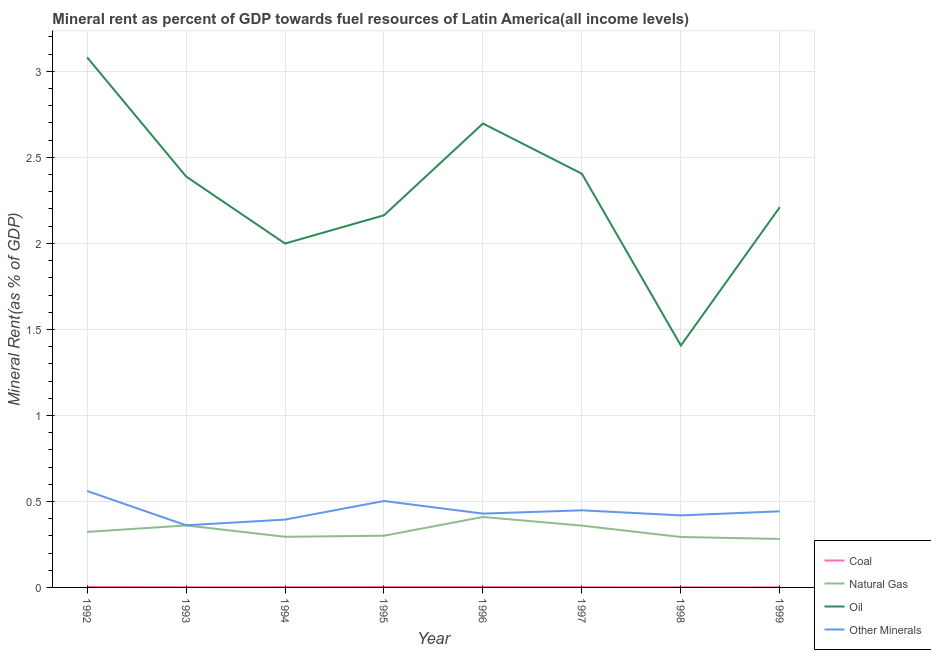Does the line corresponding to natural gas rent intersect with the line corresponding to oil rent?
Make the answer very short. No. What is the  rent of other minerals in 1995?
Ensure brevity in your answer.  0.5. Across all years, what is the maximum  rent of other minerals?
Provide a succinct answer. 0.56. Across all years, what is the minimum coal rent?
Offer a very short reply. 0. In which year was the  rent of other minerals maximum?
Make the answer very short. 1992. In which year was the  rent of other minerals minimum?
Offer a very short reply. 1993. What is the total  rent of other minerals in the graph?
Make the answer very short. 3.56. What is the difference between the natural gas rent in 1993 and that in 1994?
Make the answer very short. 0.07. What is the difference between the oil rent in 1997 and the coal rent in 1994?
Ensure brevity in your answer.  2.4. What is the average coal rent per year?
Your answer should be very brief. 0. In the year 1998, what is the difference between the  rent of other minerals and natural gas rent?
Ensure brevity in your answer.  0.13. What is the ratio of the oil rent in 1994 to that in 1997?
Provide a short and direct response. 0.83. What is the difference between the highest and the second highest  rent of other minerals?
Provide a succinct answer. 0.06. What is the difference between the highest and the lowest  rent of other minerals?
Offer a very short reply. 0.2. In how many years, is the  rent of other minerals greater than the average  rent of other minerals taken over all years?
Your answer should be very brief. 3. Does the natural gas rent monotonically increase over the years?
Offer a very short reply. No. Is the coal rent strictly less than the natural gas rent over the years?
Offer a terse response. Yes. What is the difference between two consecutive major ticks on the Y-axis?
Keep it short and to the point. 0.5. Are the values on the major ticks of Y-axis written in scientific E-notation?
Make the answer very short. No. Where does the legend appear in the graph?
Ensure brevity in your answer.  Bottom right. What is the title of the graph?
Your answer should be compact. Mineral rent as percent of GDP towards fuel resources of Latin America(all income levels). What is the label or title of the X-axis?
Your answer should be compact. Year. What is the label or title of the Y-axis?
Give a very brief answer. Mineral Rent(as % of GDP). What is the Mineral Rent(as % of GDP) of Coal in 1992?
Offer a very short reply. 0. What is the Mineral Rent(as % of GDP) in Natural Gas in 1992?
Your response must be concise. 0.32. What is the Mineral Rent(as % of GDP) of Oil in 1992?
Make the answer very short. 3.08. What is the Mineral Rent(as % of GDP) of Other Minerals in 1992?
Offer a terse response. 0.56. What is the Mineral Rent(as % of GDP) of Coal in 1993?
Your response must be concise. 0. What is the Mineral Rent(as % of GDP) in Natural Gas in 1993?
Keep it short and to the point. 0.36. What is the Mineral Rent(as % of GDP) of Oil in 1993?
Offer a terse response. 2.39. What is the Mineral Rent(as % of GDP) in Other Minerals in 1993?
Keep it short and to the point. 0.36. What is the Mineral Rent(as % of GDP) in Coal in 1994?
Offer a very short reply. 0. What is the Mineral Rent(as % of GDP) of Natural Gas in 1994?
Offer a terse response. 0.29. What is the Mineral Rent(as % of GDP) of Oil in 1994?
Provide a succinct answer. 2. What is the Mineral Rent(as % of GDP) in Other Minerals in 1994?
Make the answer very short. 0.39. What is the Mineral Rent(as % of GDP) in Coal in 1995?
Your answer should be compact. 0. What is the Mineral Rent(as % of GDP) of Natural Gas in 1995?
Provide a short and direct response. 0.3. What is the Mineral Rent(as % of GDP) in Oil in 1995?
Keep it short and to the point. 2.16. What is the Mineral Rent(as % of GDP) in Other Minerals in 1995?
Your response must be concise. 0.5. What is the Mineral Rent(as % of GDP) of Coal in 1996?
Your response must be concise. 0. What is the Mineral Rent(as % of GDP) in Natural Gas in 1996?
Offer a very short reply. 0.41. What is the Mineral Rent(as % of GDP) of Oil in 1996?
Your answer should be compact. 2.7. What is the Mineral Rent(as % of GDP) of Other Minerals in 1996?
Keep it short and to the point. 0.43. What is the Mineral Rent(as % of GDP) of Coal in 1997?
Keep it short and to the point. 0. What is the Mineral Rent(as % of GDP) in Natural Gas in 1997?
Your response must be concise. 0.36. What is the Mineral Rent(as % of GDP) of Oil in 1997?
Your answer should be very brief. 2.4. What is the Mineral Rent(as % of GDP) of Other Minerals in 1997?
Your answer should be very brief. 0.45. What is the Mineral Rent(as % of GDP) in Coal in 1998?
Your response must be concise. 0. What is the Mineral Rent(as % of GDP) of Natural Gas in 1998?
Make the answer very short. 0.29. What is the Mineral Rent(as % of GDP) in Oil in 1998?
Your answer should be compact. 1.41. What is the Mineral Rent(as % of GDP) of Other Minerals in 1998?
Provide a short and direct response. 0.42. What is the Mineral Rent(as % of GDP) in Coal in 1999?
Your answer should be compact. 0. What is the Mineral Rent(as % of GDP) of Natural Gas in 1999?
Make the answer very short. 0.28. What is the Mineral Rent(as % of GDP) in Oil in 1999?
Provide a succinct answer. 2.21. What is the Mineral Rent(as % of GDP) of Other Minerals in 1999?
Ensure brevity in your answer.  0.44. Across all years, what is the maximum Mineral Rent(as % of GDP) in Coal?
Ensure brevity in your answer.  0. Across all years, what is the maximum Mineral Rent(as % of GDP) of Natural Gas?
Make the answer very short. 0.41. Across all years, what is the maximum Mineral Rent(as % of GDP) of Oil?
Give a very brief answer. 3.08. Across all years, what is the maximum Mineral Rent(as % of GDP) in Other Minerals?
Keep it short and to the point. 0.56. Across all years, what is the minimum Mineral Rent(as % of GDP) in Coal?
Your response must be concise. 0. Across all years, what is the minimum Mineral Rent(as % of GDP) of Natural Gas?
Your response must be concise. 0.28. Across all years, what is the minimum Mineral Rent(as % of GDP) in Oil?
Your answer should be very brief. 1.41. Across all years, what is the minimum Mineral Rent(as % of GDP) in Other Minerals?
Offer a terse response. 0.36. What is the total Mineral Rent(as % of GDP) in Coal in the graph?
Give a very brief answer. 0.01. What is the total Mineral Rent(as % of GDP) in Natural Gas in the graph?
Offer a very short reply. 2.62. What is the total Mineral Rent(as % of GDP) of Oil in the graph?
Your answer should be compact. 18.35. What is the total Mineral Rent(as % of GDP) of Other Minerals in the graph?
Give a very brief answer. 3.56. What is the difference between the Mineral Rent(as % of GDP) of Coal in 1992 and that in 1993?
Offer a very short reply. 0. What is the difference between the Mineral Rent(as % of GDP) in Natural Gas in 1992 and that in 1993?
Ensure brevity in your answer.  -0.04. What is the difference between the Mineral Rent(as % of GDP) of Oil in 1992 and that in 1993?
Provide a succinct answer. 0.69. What is the difference between the Mineral Rent(as % of GDP) of Other Minerals in 1992 and that in 1993?
Your answer should be compact. 0.2. What is the difference between the Mineral Rent(as % of GDP) in Coal in 1992 and that in 1994?
Offer a terse response. 0. What is the difference between the Mineral Rent(as % of GDP) in Natural Gas in 1992 and that in 1994?
Offer a terse response. 0.03. What is the difference between the Mineral Rent(as % of GDP) in Oil in 1992 and that in 1994?
Ensure brevity in your answer.  1.08. What is the difference between the Mineral Rent(as % of GDP) in Other Minerals in 1992 and that in 1994?
Provide a succinct answer. 0.17. What is the difference between the Mineral Rent(as % of GDP) of Natural Gas in 1992 and that in 1995?
Offer a very short reply. 0.02. What is the difference between the Mineral Rent(as % of GDP) of Oil in 1992 and that in 1995?
Offer a very short reply. 0.92. What is the difference between the Mineral Rent(as % of GDP) of Other Minerals in 1992 and that in 1995?
Offer a very short reply. 0.06. What is the difference between the Mineral Rent(as % of GDP) in Coal in 1992 and that in 1996?
Your response must be concise. 0. What is the difference between the Mineral Rent(as % of GDP) in Natural Gas in 1992 and that in 1996?
Provide a short and direct response. -0.09. What is the difference between the Mineral Rent(as % of GDP) in Oil in 1992 and that in 1996?
Offer a terse response. 0.38. What is the difference between the Mineral Rent(as % of GDP) in Other Minerals in 1992 and that in 1996?
Ensure brevity in your answer.  0.13. What is the difference between the Mineral Rent(as % of GDP) in Coal in 1992 and that in 1997?
Your response must be concise. 0. What is the difference between the Mineral Rent(as % of GDP) in Natural Gas in 1992 and that in 1997?
Offer a terse response. -0.04. What is the difference between the Mineral Rent(as % of GDP) in Oil in 1992 and that in 1997?
Ensure brevity in your answer.  0.68. What is the difference between the Mineral Rent(as % of GDP) in Other Minerals in 1992 and that in 1997?
Your answer should be very brief. 0.11. What is the difference between the Mineral Rent(as % of GDP) in Coal in 1992 and that in 1998?
Your response must be concise. 0. What is the difference between the Mineral Rent(as % of GDP) in Natural Gas in 1992 and that in 1998?
Keep it short and to the point. 0.03. What is the difference between the Mineral Rent(as % of GDP) of Oil in 1992 and that in 1998?
Your answer should be compact. 1.68. What is the difference between the Mineral Rent(as % of GDP) of Other Minerals in 1992 and that in 1998?
Provide a short and direct response. 0.14. What is the difference between the Mineral Rent(as % of GDP) of Coal in 1992 and that in 1999?
Your answer should be very brief. 0. What is the difference between the Mineral Rent(as % of GDP) in Natural Gas in 1992 and that in 1999?
Make the answer very short. 0.04. What is the difference between the Mineral Rent(as % of GDP) in Oil in 1992 and that in 1999?
Ensure brevity in your answer.  0.87. What is the difference between the Mineral Rent(as % of GDP) in Other Minerals in 1992 and that in 1999?
Offer a very short reply. 0.12. What is the difference between the Mineral Rent(as % of GDP) of Coal in 1993 and that in 1994?
Provide a succinct answer. -0. What is the difference between the Mineral Rent(as % of GDP) in Natural Gas in 1993 and that in 1994?
Your response must be concise. 0.07. What is the difference between the Mineral Rent(as % of GDP) in Oil in 1993 and that in 1994?
Offer a very short reply. 0.39. What is the difference between the Mineral Rent(as % of GDP) in Other Minerals in 1993 and that in 1994?
Make the answer very short. -0.03. What is the difference between the Mineral Rent(as % of GDP) of Coal in 1993 and that in 1995?
Provide a succinct answer. -0. What is the difference between the Mineral Rent(as % of GDP) of Natural Gas in 1993 and that in 1995?
Ensure brevity in your answer.  0.06. What is the difference between the Mineral Rent(as % of GDP) of Oil in 1993 and that in 1995?
Ensure brevity in your answer.  0.23. What is the difference between the Mineral Rent(as % of GDP) of Other Minerals in 1993 and that in 1995?
Offer a terse response. -0.14. What is the difference between the Mineral Rent(as % of GDP) of Coal in 1993 and that in 1996?
Offer a very short reply. -0. What is the difference between the Mineral Rent(as % of GDP) in Natural Gas in 1993 and that in 1996?
Provide a succinct answer. -0.05. What is the difference between the Mineral Rent(as % of GDP) of Oil in 1993 and that in 1996?
Your answer should be very brief. -0.31. What is the difference between the Mineral Rent(as % of GDP) of Other Minerals in 1993 and that in 1996?
Provide a short and direct response. -0.07. What is the difference between the Mineral Rent(as % of GDP) in Coal in 1993 and that in 1997?
Provide a short and direct response. -0. What is the difference between the Mineral Rent(as % of GDP) in Natural Gas in 1993 and that in 1997?
Your answer should be very brief. 0. What is the difference between the Mineral Rent(as % of GDP) in Oil in 1993 and that in 1997?
Offer a terse response. -0.02. What is the difference between the Mineral Rent(as % of GDP) in Other Minerals in 1993 and that in 1997?
Offer a terse response. -0.09. What is the difference between the Mineral Rent(as % of GDP) in Coal in 1993 and that in 1998?
Keep it short and to the point. 0. What is the difference between the Mineral Rent(as % of GDP) of Natural Gas in 1993 and that in 1998?
Your response must be concise. 0.07. What is the difference between the Mineral Rent(as % of GDP) in Oil in 1993 and that in 1998?
Your answer should be very brief. 0.98. What is the difference between the Mineral Rent(as % of GDP) of Other Minerals in 1993 and that in 1998?
Your response must be concise. -0.06. What is the difference between the Mineral Rent(as % of GDP) of Coal in 1993 and that in 1999?
Ensure brevity in your answer.  0. What is the difference between the Mineral Rent(as % of GDP) of Natural Gas in 1993 and that in 1999?
Ensure brevity in your answer.  0.08. What is the difference between the Mineral Rent(as % of GDP) in Oil in 1993 and that in 1999?
Provide a short and direct response. 0.18. What is the difference between the Mineral Rent(as % of GDP) of Other Minerals in 1993 and that in 1999?
Ensure brevity in your answer.  -0.08. What is the difference between the Mineral Rent(as % of GDP) of Coal in 1994 and that in 1995?
Keep it short and to the point. -0. What is the difference between the Mineral Rent(as % of GDP) of Natural Gas in 1994 and that in 1995?
Keep it short and to the point. -0.01. What is the difference between the Mineral Rent(as % of GDP) of Oil in 1994 and that in 1995?
Ensure brevity in your answer.  -0.16. What is the difference between the Mineral Rent(as % of GDP) in Other Minerals in 1994 and that in 1995?
Offer a very short reply. -0.11. What is the difference between the Mineral Rent(as % of GDP) in Coal in 1994 and that in 1996?
Give a very brief answer. -0. What is the difference between the Mineral Rent(as % of GDP) in Natural Gas in 1994 and that in 1996?
Provide a succinct answer. -0.12. What is the difference between the Mineral Rent(as % of GDP) in Oil in 1994 and that in 1996?
Offer a terse response. -0.7. What is the difference between the Mineral Rent(as % of GDP) of Other Minerals in 1994 and that in 1996?
Your answer should be very brief. -0.03. What is the difference between the Mineral Rent(as % of GDP) in Coal in 1994 and that in 1997?
Ensure brevity in your answer.  -0. What is the difference between the Mineral Rent(as % of GDP) of Natural Gas in 1994 and that in 1997?
Offer a terse response. -0.06. What is the difference between the Mineral Rent(as % of GDP) of Oil in 1994 and that in 1997?
Provide a short and direct response. -0.41. What is the difference between the Mineral Rent(as % of GDP) in Other Minerals in 1994 and that in 1997?
Your answer should be very brief. -0.05. What is the difference between the Mineral Rent(as % of GDP) of Coal in 1994 and that in 1998?
Offer a very short reply. 0. What is the difference between the Mineral Rent(as % of GDP) in Natural Gas in 1994 and that in 1998?
Give a very brief answer. 0. What is the difference between the Mineral Rent(as % of GDP) of Oil in 1994 and that in 1998?
Give a very brief answer. 0.59. What is the difference between the Mineral Rent(as % of GDP) in Other Minerals in 1994 and that in 1998?
Your response must be concise. -0.02. What is the difference between the Mineral Rent(as % of GDP) of Coal in 1994 and that in 1999?
Your answer should be compact. 0. What is the difference between the Mineral Rent(as % of GDP) of Natural Gas in 1994 and that in 1999?
Offer a terse response. 0.01. What is the difference between the Mineral Rent(as % of GDP) of Oil in 1994 and that in 1999?
Provide a succinct answer. -0.21. What is the difference between the Mineral Rent(as % of GDP) of Other Minerals in 1994 and that in 1999?
Offer a terse response. -0.05. What is the difference between the Mineral Rent(as % of GDP) in Coal in 1995 and that in 1996?
Offer a terse response. 0. What is the difference between the Mineral Rent(as % of GDP) of Natural Gas in 1995 and that in 1996?
Your answer should be very brief. -0.11. What is the difference between the Mineral Rent(as % of GDP) of Oil in 1995 and that in 1996?
Offer a very short reply. -0.53. What is the difference between the Mineral Rent(as % of GDP) of Other Minerals in 1995 and that in 1996?
Your answer should be compact. 0.07. What is the difference between the Mineral Rent(as % of GDP) of Natural Gas in 1995 and that in 1997?
Offer a terse response. -0.06. What is the difference between the Mineral Rent(as % of GDP) in Oil in 1995 and that in 1997?
Your answer should be very brief. -0.24. What is the difference between the Mineral Rent(as % of GDP) in Other Minerals in 1995 and that in 1997?
Give a very brief answer. 0.05. What is the difference between the Mineral Rent(as % of GDP) in Coal in 1995 and that in 1998?
Offer a terse response. 0. What is the difference between the Mineral Rent(as % of GDP) in Natural Gas in 1995 and that in 1998?
Give a very brief answer. 0.01. What is the difference between the Mineral Rent(as % of GDP) in Oil in 1995 and that in 1998?
Provide a succinct answer. 0.76. What is the difference between the Mineral Rent(as % of GDP) of Other Minerals in 1995 and that in 1998?
Your response must be concise. 0.08. What is the difference between the Mineral Rent(as % of GDP) in Coal in 1995 and that in 1999?
Offer a very short reply. 0. What is the difference between the Mineral Rent(as % of GDP) in Natural Gas in 1995 and that in 1999?
Provide a short and direct response. 0.02. What is the difference between the Mineral Rent(as % of GDP) of Oil in 1995 and that in 1999?
Offer a terse response. -0.05. What is the difference between the Mineral Rent(as % of GDP) in Other Minerals in 1995 and that in 1999?
Keep it short and to the point. 0.06. What is the difference between the Mineral Rent(as % of GDP) of Coal in 1996 and that in 1997?
Keep it short and to the point. 0. What is the difference between the Mineral Rent(as % of GDP) in Natural Gas in 1996 and that in 1997?
Offer a very short reply. 0.05. What is the difference between the Mineral Rent(as % of GDP) in Oil in 1996 and that in 1997?
Keep it short and to the point. 0.29. What is the difference between the Mineral Rent(as % of GDP) in Other Minerals in 1996 and that in 1997?
Give a very brief answer. -0.02. What is the difference between the Mineral Rent(as % of GDP) in Coal in 1996 and that in 1998?
Offer a very short reply. 0. What is the difference between the Mineral Rent(as % of GDP) in Natural Gas in 1996 and that in 1998?
Make the answer very short. 0.12. What is the difference between the Mineral Rent(as % of GDP) of Oil in 1996 and that in 1998?
Keep it short and to the point. 1.29. What is the difference between the Mineral Rent(as % of GDP) in Other Minerals in 1996 and that in 1998?
Offer a very short reply. 0.01. What is the difference between the Mineral Rent(as % of GDP) in Coal in 1996 and that in 1999?
Offer a very short reply. 0. What is the difference between the Mineral Rent(as % of GDP) in Natural Gas in 1996 and that in 1999?
Provide a short and direct response. 0.13. What is the difference between the Mineral Rent(as % of GDP) of Oil in 1996 and that in 1999?
Your answer should be compact. 0.49. What is the difference between the Mineral Rent(as % of GDP) in Other Minerals in 1996 and that in 1999?
Your answer should be very brief. -0.01. What is the difference between the Mineral Rent(as % of GDP) in Coal in 1997 and that in 1998?
Make the answer very short. 0. What is the difference between the Mineral Rent(as % of GDP) of Natural Gas in 1997 and that in 1998?
Your answer should be very brief. 0.07. What is the difference between the Mineral Rent(as % of GDP) in Other Minerals in 1997 and that in 1998?
Give a very brief answer. 0.03. What is the difference between the Mineral Rent(as % of GDP) in Coal in 1997 and that in 1999?
Your answer should be very brief. 0. What is the difference between the Mineral Rent(as % of GDP) in Natural Gas in 1997 and that in 1999?
Provide a short and direct response. 0.08. What is the difference between the Mineral Rent(as % of GDP) in Oil in 1997 and that in 1999?
Your answer should be compact. 0.19. What is the difference between the Mineral Rent(as % of GDP) of Other Minerals in 1997 and that in 1999?
Keep it short and to the point. 0.01. What is the difference between the Mineral Rent(as % of GDP) of Natural Gas in 1998 and that in 1999?
Offer a terse response. 0.01. What is the difference between the Mineral Rent(as % of GDP) in Oil in 1998 and that in 1999?
Your answer should be compact. -0.8. What is the difference between the Mineral Rent(as % of GDP) in Other Minerals in 1998 and that in 1999?
Offer a very short reply. -0.02. What is the difference between the Mineral Rent(as % of GDP) of Coal in 1992 and the Mineral Rent(as % of GDP) of Natural Gas in 1993?
Your answer should be compact. -0.36. What is the difference between the Mineral Rent(as % of GDP) in Coal in 1992 and the Mineral Rent(as % of GDP) in Oil in 1993?
Your response must be concise. -2.39. What is the difference between the Mineral Rent(as % of GDP) in Coal in 1992 and the Mineral Rent(as % of GDP) in Other Minerals in 1993?
Provide a succinct answer. -0.36. What is the difference between the Mineral Rent(as % of GDP) in Natural Gas in 1992 and the Mineral Rent(as % of GDP) in Oil in 1993?
Your answer should be very brief. -2.07. What is the difference between the Mineral Rent(as % of GDP) in Natural Gas in 1992 and the Mineral Rent(as % of GDP) in Other Minerals in 1993?
Make the answer very short. -0.04. What is the difference between the Mineral Rent(as % of GDP) of Oil in 1992 and the Mineral Rent(as % of GDP) of Other Minerals in 1993?
Your response must be concise. 2.72. What is the difference between the Mineral Rent(as % of GDP) of Coal in 1992 and the Mineral Rent(as % of GDP) of Natural Gas in 1994?
Give a very brief answer. -0.29. What is the difference between the Mineral Rent(as % of GDP) in Coal in 1992 and the Mineral Rent(as % of GDP) in Oil in 1994?
Your answer should be compact. -2. What is the difference between the Mineral Rent(as % of GDP) of Coal in 1992 and the Mineral Rent(as % of GDP) of Other Minerals in 1994?
Ensure brevity in your answer.  -0.39. What is the difference between the Mineral Rent(as % of GDP) in Natural Gas in 1992 and the Mineral Rent(as % of GDP) in Oil in 1994?
Keep it short and to the point. -1.68. What is the difference between the Mineral Rent(as % of GDP) in Natural Gas in 1992 and the Mineral Rent(as % of GDP) in Other Minerals in 1994?
Your response must be concise. -0.07. What is the difference between the Mineral Rent(as % of GDP) of Oil in 1992 and the Mineral Rent(as % of GDP) of Other Minerals in 1994?
Ensure brevity in your answer.  2.69. What is the difference between the Mineral Rent(as % of GDP) of Coal in 1992 and the Mineral Rent(as % of GDP) of Natural Gas in 1995?
Give a very brief answer. -0.3. What is the difference between the Mineral Rent(as % of GDP) in Coal in 1992 and the Mineral Rent(as % of GDP) in Oil in 1995?
Keep it short and to the point. -2.16. What is the difference between the Mineral Rent(as % of GDP) in Coal in 1992 and the Mineral Rent(as % of GDP) in Other Minerals in 1995?
Your answer should be very brief. -0.5. What is the difference between the Mineral Rent(as % of GDP) of Natural Gas in 1992 and the Mineral Rent(as % of GDP) of Oil in 1995?
Your response must be concise. -1.84. What is the difference between the Mineral Rent(as % of GDP) of Natural Gas in 1992 and the Mineral Rent(as % of GDP) of Other Minerals in 1995?
Keep it short and to the point. -0.18. What is the difference between the Mineral Rent(as % of GDP) of Oil in 1992 and the Mineral Rent(as % of GDP) of Other Minerals in 1995?
Your response must be concise. 2.58. What is the difference between the Mineral Rent(as % of GDP) in Coal in 1992 and the Mineral Rent(as % of GDP) in Natural Gas in 1996?
Offer a terse response. -0.41. What is the difference between the Mineral Rent(as % of GDP) of Coal in 1992 and the Mineral Rent(as % of GDP) of Oil in 1996?
Your response must be concise. -2.69. What is the difference between the Mineral Rent(as % of GDP) in Coal in 1992 and the Mineral Rent(as % of GDP) in Other Minerals in 1996?
Ensure brevity in your answer.  -0.43. What is the difference between the Mineral Rent(as % of GDP) of Natural Gas in 1992 and the Mineral Rent(as % of GDP) of Oil in 1996?
Your response must be concise. -2.37. What is the difference between the Mineral Rent(as % of GDP) in Natural Gas in 1992 and the Mineral Rent(as % of GDP) in Other Minerals in 1996?
Your response must be concise. -0.11. What is the difference between the Mineral Rent(as % of GDP) in Oil in 1992 and the Mineral Rent(as % of GDP) in Other Minerals in 1996?
Provide a short and direct response. 2.65. What is the difference between the Mineral Rent(as % of GDP) in Coal in 1992 and the Mineral Rent(as % of GDP) in Natural Gas in 1997?
Your answer should be compact. -0.36. What is the difference between the Mineral Rent(as % of GDP) in Coal in 1992 and the Mineral Rent(as % of GDP) in Oil in 1997?
Provide a succinct answer. -2.4. What is the difference between the Mineral Rent(as % of GDP) of Coal in 1992 and the Mineral Rent(as % of GDP) of Other Minerals in 1997?
Give a very brief answer. -0.45. What is the difference between the Mineral Rent(as % of GDP) of Natural Gas in 1992 and the Mineral Rent(as % of GDP) of Oil in 1997?
Keep it short and to the point. -2.08. What is the difference between the Mineral Rent(as % of GDP) in Natural Gas in 1992 and the Mineral Rent(as % of GDP) in Other Minerals in 1997?
Make the answer very short. -0.13. What is the difference between the Mineral Rent(as % of GDP) of Oil in 1992 and the Mineral Rent(as % of GDP) of Other Minerals in 1997?
Offer a terse response. 2.63. What is the difference between the Mineral Rent(as % of GDP) in Coal in 1992 and the Mineral Rent(as % of GDP) in Natural Gas in 1998?
Keep it short and to the point. -0.29. What is the difference between the Mineral Rent(as % of GDP) of Coal in 1992 and the Mineral Rent(as % of GDP) of Oil in 1998?
Ensure brevity in your answer.  -1.4. What is the difference between the Mineral Rent(as % of GDP) in Coal in 1992 and the Mineral Rent(as % of GDP) in Other Minerals in 1998?
Offer a very short reply. -0.42. What is the difference between the Mineral Rent(as % of GDP) of Natural Gas in 1992 and the Mineral Rent(as % of GDP) of Oil in 1998?
Ensure brevity in your answer.  -1.08. What is the difference between the Mineral Rent(as % of GDP) in Natural Gas in 1992 and the Mineral Rent(as % of GDP) in Other Minerals in 1998?
Your answer should be compact. -0.1. What is the difference between the Mineral Rent(as % of GDP) in Oil in 1992 and the Mineral Rent(as % of GDP) in Other Minerals in 1998?
Your answer should be very brief. 2.66. What is the difference between the Mineral Rent(as % of GDP) in Coal in 1992 and the Mineral Rent(as % of GDP) in Natural Gas in 1999?
Ensure brevity in your answer.  -0.28. What is the difference between the Mineral Rent(as % of GDP) in Coal in 1992 and the Mineral Rent(as % of GDP) in Oil in 1999?
Provide a short and direct response. -2.21. What is the difference between the Mineral Rent(as % of GDP) in Coal in 1992 and the Mineral Rent(as % of GDP) in Other Minerals in 1999?
Your response must be concise. -0.44. What is the difference between the Mineral Rent(as % of GDP) of Natural Gas in 1992 and the Mineral Rent(as % of GDP) of Oil in 1999?
Offer a very short reply. -1.89. What is the difference between the Mineral Rent(as % of GDP) in Natural Gas in 1992 and the Mineral Rent(as % of GDP) in Other Minerals in 1999?
Make the answer very short. -0.12. What is the difference between the Mineral Rent(as % of GDP) of Oil in 1992 and the Mineral Rent(as % of GDP) of Other Minerals in 1999?
Make the answer very short. 2.64. What is the difference between the Mineral Rent(as % of GDP) in Coal in 1993 and the Mineral Rent(as % of GDP) in Natural Gas in 1994?
Keep it short and to the point. -0.29. What is the difference between the Mineral Rent(as % of GDP) of Coal in 1993 and the Mineral Rent(as % of GDP) of Oil in 1994?
Provide a short and direct response. -2. What is the difference between the Mineral Rent(as % of GDP) in Coal in 1993 and the Mineral Rent(as % of GDP) in Other Minerals in 1994?
Offer a very short reply. -0.39. What is the difference between the Mineral Rent(as % of GDP) of Natural Gas in 1993 and the Mineral Rent(as % of GDP) of Oil in 1994?
Make the answer very short. -1.64. What is the difference between the Mineral Rent(as % of GDP) in Natural Gas in 1993 and the Mineral Rent(as % of GDP) in Other Minerals in 1994?
Ensure brevity in your answer.  -0.03. What is the difference between the Mineral Rent(as % of GDP) of Oil in 1993 and the Mineral Rent(as % of GDP) of Other Minerals in 1994?
Ensure brevity in your answer.  1.99. What is the difference between the Mineral Rent(as % of GDP) of Coal in 1993 and the Mineral Rent(as % of GDP) of Natural Gas in 1995?
Keep it short and to the point. -0.3. What is the difference between the Mineral Rent(as % of GDP) in Coal in 1993 and the Mineral Rent(as % of GDP) in Oil in 1995?
Provide a short and direct response. -2.16. What is the difference between the Mineral Rent(as % of GDP) of Coal in 1993 and the Mineral Rent(as % of GDP) of Other Minerals in 1995?
Your response must be concise. -0.5. What is the difference between the Mineral Rent(as % of GDP) of Natural Gas in 1993 and the Mineral Rent(as % of GDP) of Oil in 1995?
Offer a terse response. -1.8. What is the difference between the Mineral Rent(as % of GDP) of Natural Gas in 1993 and the Mineral Rent(as % of GDP) of Other Minerals in 1995?
Keep it short and to the point. -0.14. What is the difference between the Mineral Rent(as % of GDP) in Oil in 1993 and the Mineral Rent(as % of GDP) in Other Minerals in 1995?
Ensure brevity in your answer.  1.89. What is the difference between the Mineral Rent(as % of GDP) in Coal in 1993 and the Mineral Rent(as % of GDP) in Natural Gas in 1996?
Provide a short and direct response. -0.41. What is the difference between the Mineral Rent(as % of GDP) in Coal in 1993 and the Mineral Rent(as % of GDP) in Oil in 1996?
Your answer should be compact. -2.7. What is the difference between the Mineral Rent(as % of GDP) in Coal in 1993 and the Mineral Rent(as % of GDP) in Other Minerals in 1996?
Make the answer very short. -0.43. What is the difference between the Mineral Rent(as % of GDP) in Natural Gas in 1993 and the Mineral Rent(as % of GDP) in Oil in 1996?
Give a very brief answer. -2.34. What is the difference between the Mineral Rent(as % of GDP) in Natural Gas in 1993 and the Mineral Rent(as % of GDP) in Other Minerals in 1996?
Your answer should be compact. -0.07. What is the difference between the Mineral Rent(as % of GDP) in Oil in 1993 and the Mineral Rent(as % of GDP) in Other Minerals in 1996?
Make the answer very short. 1.96. What is the difference between the Mineral Rent(as % of GDP) in Coal in 1993 and the Mineral Rent(as % of GDP) in Natural Gas in 1997?
Your answer should be very brief. -0.36. What is the difference between the Mineral Rent(as % of GDP) in Coal in 1993 and the Mineral Rent(as % of GDP) in Oil in 1997?
Your answer should be very brief. -2.4. What is the difference between the Mineral Rent(as % of GDP) of Coal in 1993 and the Mineral Rent(as % of GDP) of Other Minerals in 1997?
Your response must be concise. -0.45. What is the difference between the Mineral Rent(as % of GDP) in Natural Gas in 1993 and the Mineral Rent(as % of GDP) in Oil in 1997?
Provide a succinct answer. -2.04. What is the difference between the Mineral Rent(as % of GDP) of Natural Gas in 1993 and the Mineral Rent(as % of GDP) of Other Minerals in 1997?
Your response must be concise. -0.09. What is the difference between the Mineral Rent(as % of GDP) of Oil in 1993 and the Mineral Rent(as % of GDP) of Other Minerals in 1997?
Keep it short and to the point. 1.94. What is the difference between the Mineral Rent(as % of GDP) in Coal in 1993 and the Mineral Rent(as % of GDP) in Natural Gas in 1998?
Offer a very short reply. -0.29. What is the difference between the Mineral Rent(as % of GDP) in Coal in 1993 and the Mineral Rent(as % of GDP) in Oil in 1998?
Your answer should be very brief. -1.41. What is the difference between the Mineral Rent(as % of GDP) of Coal in 1993 and the Mineral Rent(as % of GDP) of Other Minerals in 1998?
Keep it short and to the point. -0.42. What is the difference between the Mineral Rent(as % of GDP) in Natural Gas in 1993 and the Mineral Rent(as % of GDP) in Oil in 1998?
Provide a short and direct response. -1.05. What is the difference between the Mineral Rent(as % of GDP) in Natural Gas in 1993 and the Mineral Rent(as % of GDP) in Other Minerals in 1998?
Your answer should be very brief. -0.06. What is the difference between the Mineral Rent(as % of GDP) in Oil in 1993 and the Mineral Rent(as % of GDP) in Other Minerals in 1998?
Your answer should be compact. 1.97. What is the difference between the Mineral Rent(as % of GDP) of Coal in 1993 and the Mineral Rent(as % of GDP) of Natural Gas in 1999?
Your response must be concise. -0.28. What is the difference between the Mineral Rent(as % of GDP) in Coal in 1993 and the Mineral Rent(as % of GDP) in Oil in 1999?
Provide a succinct answer. -2.21. What is the difference between the Mineral Rent(as % of GDP) in Coal in 1993 and the Mineral Rent(as % of GDP) in Other Minerals in 1999?
Provide a succinct answer. -0.44. What is the difference between the Mineral Rent(as % of GDP) of Natural Gas in 1993 and the Mineral Rent(as % of GDP) of Oil in 1999?
Your answer should be very brief. -1.85. What is the difference between the Mineral Rent(as % of GDP) in Natural Gas in 1993 and the Mineral Rent(as % of GDP) in Other Minerals in 1999?
Your answer should be very brief. -0.08. What is the difference between the Mineral Rent(as % of GDP) in Oil in 1993 and the Mineral Rent(as % of GDP) in Other Minerals in 1999?
Provide a succinct answer. 1.95. What is the difference between the Mineral Rent(as % of GDP) in Coal in 1994 and the Mineral Rent(as % of GDP) in Natural Gas in 1995?
Provide a short and direct response. -0.3. What is the difference between the Mineral Rent(as % of GDP) in Coal in 1994 and the Mineral Rent(as % of GDP) in Oil in 1995?
Ensure brevity in your answer.  -2.16. What is the difference between the Mineral Rent(as % of GDP) in Coal in 1994 and the Mineral Rent(as % of GDP) in Other Minerals in 1995?
Your response must be concise. -0.5. What is the difference between the Mineral Rent(as % of GDP) of Natural Gas in 1994 and the Mineral Rent(as % of GDP) of Oil in 1995?
Ensure brevity in your answer.  -1.87. What is the difference between the Mineral Rent(as % of GDP) of Natural Gas in 1994 and the Mineral Rent(as % of GDP) of Other Minerals in 1995?
Make the answer very short. -0.21. What is the difference between the Mineral Rent(as % of GDP) in Oil in 1994 and the Mineral Rent(as % of GDP) in Other Minerals in 1995?
Provide a succinct answer. 1.5. What is the difference between the Mineral Rent(as % of GDP) in Coal in 1994 and the Mineral Rent(as % of GDP) in Natural Gas in 1996?
Make the answer very short. -0.41. What is the difference between the Mineral Rent(as % of GDP) in Coal in 1994 and the Mineral Rent(as % of GDP) in Oil in 1996?
Offer a very short reply. -2.7. What is the difference between the Mineral Rent(as % of GDP) in Coal in 1994 and the Mineral Rent(as % of GDP) in Other Minerals in 1996?
Your answer should be very brief. -0.43. What is the difference between the Mineral Rent(as % of GDP) of Natural Gas in 1994 and the Mineral Rent(as % of GDP) of Oil in 1996?
Make the answer very short. -2.4. What is the difference between the Mineral Rent(as % of GDP) of Natural Gas in 1994 and the Mineral Rent(as % of GDP) of Other Minerals in 1996?
Keep it short and to the point. -0.13. What is the difference between the Mineral Rent(as % of GDP) in Oil in 1994 and the Mineral Rent(as % of GDP) in Other Minerals in 1996?
Give a very brief answer. 1.57. What is the difference between the Mineral Rent(as % of GDP) in Coal in 1994 and the Mineral Rent(as % of GDP) in Natural Gas in 1997?
Offer a very short reply. -0.36. What is the difference between the Mineral Rent(as % of GDP) of Coal in 1994 and the Mineral Rent(as % of GDP) of Oil in 1997?
Offer a terse response. -2.4. What is the difference between the Mineral Rent(as % of GDP) of Coal in 1994 and the Mineral Rent(as % of GDP) of Other Minerals in 1997?
Your answer should be compact. -0.45. What is the difference between the Mineral Rent(as % of GDP) of Natural Gas in 1994 and the Mineral Rent(as % of GDP) of Oil in 1997?
Keep it short and to the point. -2.11. What is the difference between the Mineral Rent(as % of GDP) in Natural Gas in 1994 and the Mineral Rent(as % of GDP) in Other Minerals in 1997?
Ensure brevity in your answer.  -0.15. What is the difference between the Mineral Rent(as % of GDP) of Oil in 1994 and the Mineral Rent(as % of GDP) of Other Minerals in 1997?
Provide a short and direct response. 1.55. What is the difference between the Mineral Rent(as % of GDP) of Coal in 1994 and the Mineral Rent(as % of GDP) of Natural Gas in 1998?
Give a very brief answer. -0.29. What is the difference between the Mineral Rent(as % of GDP) in Coal in 1994 and the Mineral Rent(as % of GDP) in Oil in 1998?
Make the answer very short. -1.4. What is the difference between the Mineral Rent(as % of GDP) of Coal in 1994 and the Mineral Rent(as % of GDP) of Other Minerals in 1998?
Provide a succinct answer. -0.42. What is the difference between the Mineral Rent(as % of GDP) of Natural Gas in 1994 and the Mineral Rent(as % of GDP) of Oil in 1998?
Give a very brief answer. -1.11. What is the difference between the Mineral Rent(as % of GDP) in Natural Gas in 1994 and the Mineral Rent(as % of GDP) in Other Minerals in 1998?
Your answer should be compact. -0.12. What is the difference between the Mineral Rent(as % of GDP) of Oil in 1994 and the Mineral Rent(as % of GDP) of Other Minerals in 1998?
Make the answer very short. 1.58. What is the difference between the Mineral Rent(as % of GDP) in Coal in 1994 and the Mineral Rent(as % of GDP) in Natural Gas in 1999?
Offer a terse response. -0.28. What is the difference between the Mineral Rent(as % of GDP) of Coal in 1994 and the Mineral Rent(as % of GDP) of Oil in 1999?
Give a very brief answer. -2.21. What is the difference between the Mineral Rent(as % of GDP) of Coal in 1994 and the Mineral Rent(as % of GDP) of Other Minerals in 1999?
Give a very brief answer. -0.44. What is the difference between the Mineral Rent(as % of GDP) in Natural Gas in 1994 and the Mineral Rent(as % of GDP) in Oil in 1999?
Your response must be concise. -1.92. What is the difference between the Mineral Rent(as % of GDP) in Natural Gas in 1994 and the Mineral Rent(as % of GDP) in Other Minerals in 1999?
Offer a very short reply. -0.15. What is the difference between the Mineral Rent(as % of GDP) in Oil in 1994 and the Mineral Rent(as % of GDP) in Other Minerals in 1999?
Your answer should be compact. 1.56. What is the difference between the Mineral Rent(as % of GDP) in Coal in 1995 and the Mineral Rent(as % of GDP) in Natural Gas in 1996?
Keep it short and to the point. -0.41. What is the difference between the Mineral Rent(as % of GDP) of Coal in 1995 and the Mineral Rent(as % of GDP) of Oil in 1996?
Keep it short and to the point. -2.69. What is the difference between the Mineral Rent(as % of GDP) of Coal in 1995 and the Mineral Rent(as % of GDP) of Other Minerals in 1996?
Your response must be concise. -0.43. What is the difference between the Mineral Rent(as % of GDP) of Natural Gas in 1995 and the Mineral Rent(as % of GDP) of Oil in 1996?
Give a very brief answer. -2.4. What is the difference between the Mineral Rent(as % of GDP) of Natural Gas in 1995 and the Mineral Rent(as % of GDP) of Other Minerals in 1996?
Provide a short and direct response. -0.13. What is the difference between the Mineral Rent(as % of GDP) of Oil in 1995 and the Mineral Rent(as % of GDP) of Other Minerals in 1996?
Make the answer very short. 1.73. What is the difference between the Mineral Rent(as % of GDP) in Coal in 1995 and the Mineral Rent(as % of GDP) in Natural Gas in 1997?
Provide a short and direct response. -0.36. What is the difference between the Mineral Rent(as % of GDP) in Coal in 1995 and the Mineral Rent(as % of GDP) in Oil in 1997?
Make the answer very short. -2.4. What is the difference between the Mineral Rent(as % of GDP) in Coal in 1995 and the Mineral Rent(as % of GDP) in Other Minerals in 1997?
Your answer should be compact. -0.45. What is the difference between the Mineral Rent(as % of GDP) of Natural Gas in 1995 and the Mineral Rent(as % of GDP) of Oil in 1997?
Your answer should be compact. -2.1. What is the difference between the Mineral Rent(as % of GDP) of Natural Gas in 1995 and the Mineral Rent(as % of GDP) of Other Minerals in 1997?
Provide a short and direct response. -0.15. What is the difference between the Mineral Rent(as % of GDP) of Oil in 1995 and the Mineral Rent(as % of GDP) of Other Minerals in 1997?
Your response must be concise. 1.72. What is the difference between the Mineral Rent(as % of GDP) in Coal in 1995 and the Mineral Rent(as % of GDP) in Natural Gas in 1998?
Provide a short and direct response. -0.29. What is the difference between the Mineral Rent(as % of GDP) of Coal in 1995 and the Mineral Rent(as % of GDP) of Oil in 1998?
Provide a short and direct response. -1.4. What is the difference between the Mineral Rent(as % of GDP) of Coal in 1995 and the Mineral Rent(as % of GDP) of Other Minerals in 1998?
Keep it short and to the point. -0.42. What is the difference between the Mineral Rent(as % of GDP) in Natural Gas in 1995 and the Mineral Rent(as % of GDP) in Oil in 1998?
Give a very brief answer. -1.11. What is the difference between the Mineral Rent(as % of GDP) in Natural Gas in 1995 and the Mineral Rent(as % of GDP) in Other Minerals in 1998?
Offer a terse response. -0.12. What is the difference between the Mineral Rent(as % of GDP) in Oil in 1995 and the Mineral Rent(as % of GDP) in Other Minerals in 1998?
Your answer should be compact. 1.74. What is the difference between the Mineral Rent(as % of GDP) of Coal in 1995 and the Mineral Rent(as % of GDP) of Natural Gas in 1999?
Ensure brevity in your answer.  -0.28. What is the difference between the Mineral Rent(as % of GDP) of Coal in 1995 and the Mineral Rent(as % of GDP) of Oil in 1999?
Keep it short and to the point. -2.21. What is the difference between the Mineral Rent(as % of GDP) of Coal in 1995 and the Mineral Rent(as % of GDP) of Other Minerals in 1999?
Provide a short and direct response. -0.44. What is the difference between the Mineral Rent(as % of GDP) in Natural Gas in 1995 and the Mineral Rent(as % of GDP) in Oil in 1999?
Provide a succinct answer. -1.91. What is the difference between the Mineral Rent(as % of GDP) of Natural Gas in 1995 and the Mineral Rent(as % of GDP) of Other Minerals in 1999?
Provide a succinct answer. -0.14. What is the difference between the Mineral Rent(as % of GDP) of Oil in 1995 and the Mineral Rent(as % of GDP) of Other Minerals in 1999?
Give a very brief answer. 1.72. What is the difference between the Mineral Rent(as % of GDP) of Coal in 1996 and the Mineral Rent(as % of GDP) of Natural Gas in 1997?
Your response must be concise. -0.36. What is the difference between the Mineral Rent(as % of GDP) in Coal in 1996 and the Mineral Rent(as % of GDP) in Oil in 1997?
Keep it short and to the point. -2.4. What is the difference between the Mineral Rent(as % of GDP) of Coal in 1996 and the Mineral Rent(as % of GDP) of Other Minerals in 1997?
Provide a short and direct response. -0.45. What is the difference between the Mineral Rent(as % of GDP) in Natural Gas in 1996 and the Mineral Rent(as % of GDP) in Oil in 1997?
Provide a short and direct response. -2. What is the difference between the Mineral Rent(as % of GDP) in Natural Gas in 1996 and the Mineral Rent(as % of GDP) in Other Minerals in 1997?
Keep it short and to the point. -0.04. What is the difference between the Mineral Rent(as % of GDP) of Oil in 1996 and the Mineral Rent(as % of GDP) of Other Minerals in 1997?
Keep it short and to the point. 2.25. What is the difference between the Mineral Rent(as % of GDP) in Coal in 1996 and the Mineral Rent(as % of GDP) in Natural Gas in 1998?
Your response must be concise. -0.29. What is the difference between the Mineral Rent(as % of GDP) of Coal in 1996 and the Mineral Rent(as % of GDP) of Oil in 1998?
Your answer should be compact. -1.4. What is the difference between the Mineral Rent(as % of GDP) in Coal in 1996 and the Mineral Rent(as % of GDP) in Other Minerals in 1998?
Provide a short and direct response. -0.42. What is the difference between the Mineral Rent(as % of GDP) of Natural Gas in 1996 and the Mineral Rent(as % of GDP) of Oil in 1998?
Your answer should be very brief. -1. What is the difference between the Mineral Rent(as % of GDP) in Natural Gas in 1996 and the Mineral Rent(as % of GDP) in Other Minerals in 1998?
Offer a very short reply. -0.01. What is the difference between the Mineral Rent(as % of GDP) of Oil in 1996 and the Mineral Rent(as % of GDP) of Other Minerals in 1998?
Your answer should be compact. 2.28. What is the difference between the Mineral Rent(as % of GDP) of Coal in 1996 and the Mineral Rent(as % of GDP) of Natural Gas in 1999?
Provide a short and direct response. -0.28. What is the difference between the Mineral Rent(as % of GDP) of Coal in 1996 and the Mineral Rent(as % of GDP) of Oil in 1999?
Keep it short and to the point. -2.21. What is the difference between the Mineral Rent(as % of GDP) in Coal in 1996 and the Mineral Rent(as % of GDP) in Other Minerals in 1999?
Ensure brevity in your answer.  -0.44. What is the difference between the Mineral Rent(as % of GDP) of Natural Gas in 1996 and the Mineral Rent(as % of GDP) of Oil in 1999?
Ensure brevity in your answer.  -1.8. What is the difference between the Mineral Rent(as % of GDP) in Natural Gas in 1996 and the Mineral Rent(as % of GDP) in Other Minerals in 1999?
Ensure brevity in your answer.  -0.03. What is the difference between the Mineral Rent(as % of GDP) in Oil in 1996 and the Mineral Rent(as % of GDP) in Other Minerals in 1999?
Provide a short and direct response. 2.25. What is the difference between the Mineral Rent(as % of GDP) of Coal in 1997 and the Mineral Rent(as % of GDP) of Natural Gas in 1998?
Provide a succinct answer. -0.29. What is the difference between the Mineral Rent(as % of GDP) in Coal in 1997 and the Mineral Rent(as % of GDP) in Oil in 1998?
Provide a succinct answer. -1.4. What is the difference between the Mineral Rent(as % of GDP) in Coal in 1997 and the Mineral Rent(as % of GDP) in Other Minerals in 1998?
Offer a very short reply. -0.42. What is the difference between the Mineral Rent(as % of GDP) in Natural Gas in 1997 and the Mineral Rent(as % of GDP) in Oil in 1998?
Ensure brevity in your answer.  -1.05. What is the difference between the Mineral Rent(as % of GDP) of Natural Gas in 1997 and the Mineral Rent(as % of GDP) of Other Minerals in 1998?
Provide a succinct answer. -0.06. What is the difference between the Mineral Rent(as % of GDP) in Oil in 1997 and the Mineral Rent(as % of GDP) in Other Minerals in 1998?
Ensure brevity in your answer.  1.99. What is the difference between the Mineral Rent(as % of GDP) of Coal in 1997 and the Mineral Rent(as % of GDP) of Natural Gas in 1999?
Offer a very short reply. -0.28. What is the difference between the Mineral Rent(as % of GDP) of Coal in 1997 and the Mineral Rent(as % of GDP) of Oil in 1999?
Ensure brevity in your answer.  -2.21. What is the difference between the Mineral Rent(as % of GDP) in Coal in 1997 and the Mineral Rent(as % of GDP) in Other Minerals in 1999?
Keep it short and to the point. -0.44. What is the difference between the Mineral Rent(as % of GDP) of Natural Gas in 1997 and the Mineral Rent(as % of GDP) of Oil in 1999?
Make the answer very short. -1.85. What is the difference between the Mineral Rent(as % of GDP) of Natural Gas in 1997 and the Mineral Rent(as % of GDP) of Other Minerals in 1999?
Your answer should be very brief. -0.08. What is the difference between the Mineral Rent(as % of GDP) in Oil in 1997 and the Mineral Rent(as % of GDP) in Other Minerals in 1999?
Provide a succinct answer. 1.96. What is the difference between the Mineral Rent(as % of GDP) of Coal in 1998 and the Mineral Rent(as % of GDP) of Natural Gas in 1999?
Ensure brevity in your answer.  -0.28. What is the difference between the Mineral Rent(as % of GDP) in Coal in 1998 and the Mineral Rent(as % of GDP) in Oil in 1999?
Give a very brief answer. -2.21. What is the difference between the Mineral Rent(as % of GDP) in Coal in 1998 and the Mineral Rent(as % of GDP) in Other Minerals in 1999?
Your answer should be compact. -0.44. What is the difference between the Mineral Rent(as % of GDP) in Natural Gas in 1998 and the Mineral Rent(as % of GDP) in Oil in 1999?
Your answer should be compact. -1.92. What is the difference between the Mineral Rent(as % of GDP) in Natural Gas in 1998 and the Mineral Rent(as % of GDP) in Other Minerals in 1999?
Your answer should be very brief. -0.15. What is the difference between the Mineral Rent(as % of GDP) in Oil in 1998 and the Mineral Rent(as % of GDP) in Other Minerals in 1999?
Make the answer very short. 0.96. What is the average Mineral Rent(as % of GDP) in Coal per year?
Make the answer very short. 0. What is the average Mineral Rent(as % of GDP) in Natural Gas per year?
Offer a terse response. 0.33. What is the average Mineral Rent(as % of GDP) in Oil per year?
Offer a very short reply. 2.29. What is the average Mineral Rent(as % of GDP) of Other Minerals per year?
Keep it short and to the point. 0.44. In the year 1992, what is the difference between the Mineral Rent(as % of GDP) in Coal and Mineral Rent(as % of GDP) in Natural Gas?
Your answer should be very brief. -0.32. In the year 1992, what is the difference between the Mineral Rent(as % of GDP) in Coal and Mineral Rent(as % of GDP) in Oil?
Your answer should be compact. -3.08. In the year 1992, what is the difference between the Mineral Rent(as % of GDP) of Coal and Mineral Rent(as % of GDP) of Other Minerals?
Offer a very short reply. -0.56. In the year 1992, what is the difference between the Mineral Rent(as % of GDP) in Natural Gas and Mineral Rent(as % of GDP) in Oil?
Provide a short and direct response. -2.76. In the year 1992, what is the difference between the Mineral Rent(as % of GDP) of Natural Gas and Mineral Rent(as % of GDP) of Other Minerals?
Give a very brief answer. -0.24. In the year 1992, what is the difference between the Mineral Rent(as % of GDP) in Oil and Mineral Rent(as % of GDP) in Other Minerals?
Your response must be concise. 2.52. In the year 1993, what is the difference between the Mineral Rent(as % of GDP) of Coal and Mineral Rent(as % of GDP) of Natural Gas?
Ensure brevity in your answer.  -0.36. In the year 1993, what is the difference between the Mineral Rent(as % of GDP) of Coal and Mineral Rent(as % of GDP) of Oil?
Ensure brevity in your answer.  -2.39. In the year 1993, what is the difference between the Mineral Rent(as % of GDP) of Coal and Mineral Rent(as % of GDP) of Other Minerals?
Offer a terse response. -0.36. In the year 1993, what is the difference between the Mineral Rent(as % of GDP) in Natural Gas and Mineral Rent(as % of GDP) in Oil?
Ensure brevity in your answer.  -2.03. In the year 1993, what is the difference between the Mineral Rent(as % of GDP) of Natural Gas and Mineral Rent(as % of GDP) of Other Minerals?
Ensure brevity in your answer.  -0. In the year 1993, what is the difference between the Mineral Rent(as % of GDP) of Oil and Mineral Rent(as % of GDP) of Other Minerals?
Offer a terse response. 2.03. In the year 1994, what is the difference between the Mineral Rent(as % of GDP) of Coal and Mineral Rent(as % of GDP) of Natural Gas?
Offer a terse response. -0.29. In the year 1994, what is the difference between the Mineral Rent(as % of GDP) in Coal and Mineral Rent(as % of GDP) in Oil?
Ensure brevity in your answer.  -2. In the year 1994, what is the difference between the Mineral Rent(as % of GDP) in Coal and Mineral Rent(as % of GDP) in Other Minerals?
Keep it short and to the point. -0.39. In the year 1994, what is the difference between the Mineral Rent(as % of GDP) of Natural Gas and Mineral Rent(as % of GDP) of Oil?
Your answer should be compact. -1.7. In the year 1994, what is the difference between the Mineral Rent(as % of GDP) of Natural Gas and Mineral Rent(as % of GDP) of Other Minerals?
Your response must be concise. -0.1. In the year 1994, what is the difference between the Mineral Rent(as % of GDP) of Oil and Mineral Rent(as % of GDP) of Other Minerals?
Provide a succinct answer. 1.6. In the year 1995, what is the difference between the Mineral Rent(as % of GDP) in Coal and Mineral Rent(as % of GDP) in Natural Gas?
Make the answer very short. -0.3. In the year 1995, what is the difference between the Mineral Rent(as % of GDP) of Coal and Mineral Rent(as % of GDP) of Oil?
Your response must be concise. -2.16. In the year 1995, what is the difference between the Mineral Rent(as % of GDP) in Coal and Mineral Rent(as % of GDP) in Other Minerals?
Your answer should be compact. -0.5. In the year 1995, what is the difference between the Mineral Rent(as % of GDP) of Natural Gas and Mineral Rent(as % of GDP) of Oil?
Offer a terse response. -1.86. In the year 1995, what is the difference between the Mineral Rent(as % of GDP) of Natural Gas and Mineral Rent(as % of GDP) of Other Minerals?
Offer a very short reply. -0.2. In the year 1995, what is the difference between the Mineral Rent(as % of GDP) in Oil and Mineral Rent(as % of GDP) in Other Minerals?
Provide a succinct answer. 1.66. In the year 1996, what is the difference between the Mineral Rent(as % of GDP) of Coal and Mineral Rent(as % of GDP) of Natural Gas?
Ensure brevity in your answer.  -0.41. In the year 1996, what is the difference between the Mineral Rent(as % of GDP) of Coal and Mineral Rent(as % of GDP) of Oil?
Your answer should be compact. -2.69. In the year 1996, what is the difference between the Mineral Rent(as % of GDP) in Coal and Mineral Rent(as % of GDP) in Other Minerals?
Your answer should be compact. -0.43. In the year 1996, what is the difference between the Mineral Rent(as % of GDP) in Natural Gas and Mineral Rent(as % of GDP) in Oil?
Give a very brief answer. -2.29. In the year 1996, what is the difference between the Mineral Rent(as % of GDP) in Natural Gas and Mineral Rent(as % of GDP) in Other Minerals?
Your response must be concise. -0.02. In the year 1996, what is the difference between the Mineral Rent(as % of GDP) of Oil and Mineral Rent(as % of GDP) of Other Minerals?
Offer a very short reply. 2.27. In the year 1997, what is the difference between the Mineral Rent(as % of GDP) in Coal and Mineral Rent(as % of GDP) in Natural Gas?
Ensure brevity in your answer.  -0.36. In the year 1997, what is the difference between the Mineral Rent(as % of GDP) of Coal and Mineral Rent(as % of GDP) of Oil?
Provide a short and direct response. -2.4. In the year 1997, what is the difference between the Mineral Rent(as % of GDP) in Coal and Mineral Rent(as % of GDP) in Other Minerals?
Offer a very short reply. -0.45. In the year 1997, what is the difference between the Mineral Rent(as % of GDP) of Natural Gas and Mineral Rent(as % of GDP) of Oil?
Your answer should be compact. -2.05. In the year 1997, what is the difference between the Mineral Rent(as % of GDP) of Natural Gas and Mineral Rent(as % of GDP) of Other Minerals?
Your answer should be compact. -0.09. In the year 1997, what is the difference between the Mineral Rent(as % of GDP) in Oil and Mineral Rent(as % of GDP) in Other Minerals?
Your answer should be compact. 1.96. In the year 1998, what is the difference between the Mineral Rent(as % of GDP) in Coal and Mineral Rent(as % of GDP) in Natural Gas?
Your answer should be very brief. -0.29. In the year 1998, what is the difference between the Mineral Rent(as % of GDP) in Coal and Mineral Rent(as % of GDP) in Oil?
Ensure brevity in your answer.  -1.41. In the year 1998, what is the difference between the Mineral Rent(as % of GDP) of Coal and Mineral Rent(as % of GDP) of Other Minerals?
Provide a succinct answer. -0.42. In the year 1998, what is the difference between the Mineral Rent(as % of GDP) of Natural Gas and Mineral Rent(as % of GDP) of Oil?
Provide a short and direct response. -1.11. In the year 1998, what is the difference between the Mineral Rent(as % of GDP) in Natural Gas and Mineral Rent(as % of GDP) in Other Minerals?
Offer a very short reply. -0.13. In the year 1999, what is the difference between the Mineral Rent(as % of GDP) in Coal and Mineral Rent(as % of GDP) in Natural Gas?
Give a very brief answer. -0.28. In the year 1999, what is the difference between the Mineral Rent(as % of GDP) of Coal and Mineral Rent(as % of GDP) of Oil?
Provide a succinct answer. -2.21. In the year 1999, what is the difference between the Mineral Rent(as % of GDP) in Coal and Mineral Rent(as % of GDP) in Other Minerals?
Ensure brevity in your answer.  -0.44. In the year 1999, what is the difference between the Mineral Rent(as % of GDP) of Natural Gas and Mineral Rent(as % of GDP) of Oil?
Give a very brief answer. -1.93. In the year 1999, what is the difference between the Mineral Rent(as % of GDP) of Natural Gas and Mineral Rent(as % of GDP) of Other Minerals?
Offer a terse response. -0.16. In the year 1999, what is the difference between the Mineral Rent(as % of GDP) of Oil and Mineral Rent(as % of GDP) of Other Minerals?
Provide a short and direct response. 1.77. What is the ratio of the Mineral Rent(as % of GDP) in Coal in 1992 to that in 1993?
Provide a succinct answer. 1.98. What is the ratio of the Mineral Rent(as % of GDP) in Natural Gas in 1992 to that in 1993?
Give a very brief answer. 0.9. What is the ratio of the Mineral Rent(as % of GDP) in Oil in 1992 to that in 1993?
Provide a succinct answer. 1.29. What is the ratio of the Mineral Rent(as % of GDP) of Other Minerals in 1992 to that in 1993?
Offer a terse response. 1.55. What is the ratio of the Mineral Rent(as % of GDP) in Coal in 1992 to that in 1994?
Keep it short and to the point. 1.81. What is the ratio of the Mineral Rent(as % of GDP) of Natural Gas in 1992 to that in 1994?
Provide a succinct answer. 1.1. What is the ratio of the Mineral Rent(as % of GDP) of Oil in 1992 to that in 1994?
Your response must be concise. 1.54. What is the ratio of the Mineral Rent(as % of GDP) of Other Minerals in 1992 to that in 1994?
Provide a succinct answer. 1.42. What is the ratio of the Mineral Rent(as % of GDP) in Coal in 1992 to that in 1995?
Provide a succinct answer. 1.08. What is the ratio of the Mineral Rent(as % of GDP) in Natural Gas in 1992 to that in 1995?
Your answer should be very brief. 1.07. What is the ratio of the Mineral Rent(as % of GDP) of Oil in 1992 to that in 1995?
Offer a very short reply. 1.42. What is the ratio of the Mineral Rent(as % of GDP) of Other Minerals in 1992 to that in 1995?
Provide a short and direct response. 1.12. What is the ratio of the Mineral Rent(as % of GDP) in Coal in 1992 to that in 1996?
Provide a succinct answer. 1.25. What is the ratio of the Mineral Rent(as % of GDP) of Natural Gas in 1992 to that in 1996?
Ensure brevity in your answer.  0.79. What is the ratio of the Mineral Rent(as % of GDP) of Oil in 1992 to that in 1996?
Give a very brief answer. 1.14. What is the ratio of the Mineral Rent(as % of GDP) in Other Minerals in 1992 to that in 1996?
Keep it short and to the point. 1.31. What is the ratio of the Mineral Rent(as % of GDP) of Coal in 1992 to that in 1997?
Your response must be concise. 1.72. What is the ratio of the Mineral Rent(as % of GDP) in Natural Gas in 1992 to that in 1997?
Your response must be concise. 0.9. What is the ratio of the Mineral Rent(as % of GDP) of Oil in 1992 to that in 1997?
Your answer should be compact. 1.28. What is the ratio of the Mineral Rent(as % of GDP) of Other Minerals in 1992 to that in 1997?
Your answer should be compact. 1.25. What is the ratio of the Mineral Rent(as % of GDP) in Coal in 1992 to that in 1998?
Your answer should be very brief. 3.43. What is the ratio of the Mineral Rent(as % of GDP) in Natural Gas in 1992 to that in 1998?
Your answer should be compact. 1.1. What is the ratio of the Mineral Rent(as % of GDP) in Oil in 1992 to that in 1998?
Offer a terse response. 2.19. What is the ratio of the Mineral Rent(as % of GDP) in Other Minerals in 1992 to that in 1998?
Your answer should be compact. 1.34. What is the ratio of the Mineral Rent(as % of GDP) of Coal in 1992 to that in 1999?
Offer a very short reply. 5. What is the ratio of the Mineral Rent(as % of GDP) of Natural Gas in 1992 to that in 1999?
Your answer should be compact. 1.14. What is the ratio of the Mineral Rent(as % of GDP) of Oil in 1992 to that in 1999?
Keep it short and to the point. 1.39. What is the ratio of the Mineral Rent(as % of GDP) in Other Minerals in 1992 to that in 1999?
Give a very brief answer. 1.27. What is the ratio of the Mineral Rent(as % of GDP) of Coal in 1993 to that in 1994?
Your answer should be very brief. 0.92. What is the ratio of the Mineral Rent(as % of GDP) in Natural Gas in 1993 to that in 1994?
Make the answer very short. 1.22. What is the ratio of the Mineral Rent(as % of GDP) in Oil in 1993 to that in 1994?
Your answer should be very brief. 1.2. What is the ratio of the Mineral Rent(as % of GDP) in Other Minerals in 1993 to that in 1994?
Make the answer very short. 0.92. What is the ratio of the Mineral Rent(as % of GDP) in Coal in 1993 to that in 1995?
Offer a terse response. 0.55. What is the ratio of the Mineral Rent(as % of GDP) of Natural Gas in 1993 to that in 1995?
Your answer should be very brief. 1.2. What is the ratio of the Mineral Rent(as % of GDP) in Oil in 1993 to that in 1995?
Ensure brevity in your answer.  1.1. What is the ratio of the Mineral Rent(as % of GDP) in Other Minerals in 1993 to that in 1995?
Offer a very short reply. 0.72. What is the ratio of the Mineral Rent(as % of GDP) of Coal in 1993 to that in 1996?
Give a very brief answer. 0.63. What is the ratio of the Mineral Rent(as % of GDP) of Natural Gas in 1993 to that in 1996?
Give a very brief answer. 0.88. What is the ratio of the Mineral Rent(as % of GDP) of Oil in 1993 to that in 1996?
Keep it short and to the point. 0.89. What is the ratio of the Mineral Rent(as % of GDP) in Other Minerals in 1993 to that in 1996?
Make the answer very short. 0.84. What is the ratio of the Mineral Rent(as % of GDP) in Coal in 1993 to that in 1997?
Your response must be concise. 0.87. What is the ratio of the Mineral Rent(as % of GDP) in Oil in 1993 to that in 1997?
Make the answer very short. 0.99. What is the ratio of the Mineral Rent(as % of GDP) of Other Minerals in 1993 to that in 1997?
Provide a short and direct response. 0.81. What is the ratio of the Mineral Rent(as % of GDP) in Coal in 1993 to that in 1998?
Your answer should be very brief. 1.73. What is the ratio of the Mineral Rent(as % of GDP) of Natural Gas in 1993 to that in 1998?
Give a very brief answer. 1.23. What is the ratio of the Mineral Rent(as % of GDP) of Oil in 1993 to that in 1998?
Give a very brief answer. 1.7. What is the ratio of the Mineral Rent(as % of GDP) of Other Minerals in 1993 to that in 1998?
Offer a terse response. 0.86. What is the ratio of the Mineral Rent(as % of GDP) of Coal in 1993 to that in 1999?
Keep it short and to the point. 2.53. What is the ratio of the Mineral Rent(as % of GDP) of Natural Gas in 1993 to that in 1999?
Keep it short and to the point. 1.28. What is the ratio of the Mineral Rent(as % of GDP) in Oil in 1993 to that in 1999?
Ensure brevity in your answer.  1.08. What is the ratio of the Mineral Rent(as % of GDP) of Other Minerals in 1993 to that in 1999?
Your answer should be very brief. 0.82. What is the ratio of the Mineral Rent(as % of GDP) in Coal in 1994 to that in 1995?
Offer a terse response. 0.6. What is the ratio of the Mineral Rent(as % of GDP) of Natural Gas in 1994 to that in 1995?
Offer a terse response. 0.98. What is the ratio of the Mineral Rent(as % of GDP) in Oil in 1994 to that in 1995?
Offer a terse response. 0.92. What is the ratio of the Mineral Rent(as % of GDP) of Other Minerals in 1994 to that in 1995?
Offer a terse response. 0.78. What is the ratio of the Mineral Rent(as % of GDP) in Coal in 1994 to that in 1996?
Give a very brief answer. 0.69. What is the ratio of the Mineral Rent(as % of GDP) of Natural Gas in 1994 to that in 1996?
Ensure brevity in your answer.  0.72. What is the ratio of the Mineral Rent(as % of GDP) of Oil in 1994 to that in 1996?
Offer a very short reply. 0.74. What is the ratio of the Mineral Rent(as % of GDP) of Other Minerals in 1994 to that in 1996?
Provide a short and direct response. 0.92. What is the ratio of the Mineral Rent(as % of GDP) in Coal in 1994 to that in 1997?
Offer a very short reply. 0.95. What is the ratio of the Mineral Rent(as % of GDP) in Natural Gas in 1994 to that in 1997?
Ensure brevity in your answer.  0.82. What is the ratio of the Mineral Rent(as % of GDP) of Oil in 1994 to that in 1997?
Provide a short and direct response. 0.83. What is the ratio of the Mineral Rent(as % of GDP) in Other Minerals in 1994 to that in 1997?
Make the answer very short. 0.88. What is the ratio of the Mineral Rent(as % of GDP) of Coal in 1994 to that in 1998?
Give a very brief answer. 1.89. What is the ratio of the Mineral Rent(as % of GDP) of Natural Gas in 1994 to that in 1998?
Make the answer very short. 1. What is the ratio of the Mineral Rent(as % of GDP) of Oil in 1994 to that in 1998?
Offer a terse response. 1.42. What is the ratio of the Mineral Rent(as % of GDP) in Other Minerals in 1994 to that in 1998?
Your response must be concise. 0.94. What is the ratio of the Mineral Rent(as % of GDP) of Coal in 1994 to that in 1999?
Ensure brevity in your answer.  2.76. What is the ratio of the Mineral Rent(as % of GDP) of Natural Gas in 1994 to that in 1999?
Give a very brief answer. 1.04. What is the ratio of the Mineral Rent(as % of GDP) of Oil in 1994 to that in 1999?
Make the answer very short. 0.9. What is the ratio of the Mineral Rent(as % of GDP) of Other Minerals in 1994 to that in 1999?
Your answer should be very brief. 0.89. What is the ratio of the Mineral Rent(as % of GDP) of Coal in 1995 to that in 1996?
Keep it short and to the point. 1.16. What is the ratio of the Mineral Rent(as % of GDP) of Natural Gas in 1995 to that in 1996?
Your answer should be compact. 0.73. What is the ratio of the Mineral Rent(as % of GDP) of Oil in 1995 to that in 1996?
Offer a very short reply. 0.8. What is the ratio of the Mineral Rent(as % of GDP) in Other Minerals in 1995 to that in 1996?
Make the answer very short. 1.17. What is the ratio of the Mineral Rent(as % of GDP) in Coal in 1995 to that in 1997?
Offer a very short reply. 1.59. What is the ratio of the Mineral Rent(as % of GDP) of Natural Gas in 1995 to that in 1997?
Your answer should be very brief. 0.84. What is the ratio of the Mineral Rent(as % of GDP) of Oil in 1995 to that in 1997?
Your answer should be compact. 0.9. What is the ratio of the Mineral Rent(as % of GDP) of Other Minerals in 1995 to that in 1997?
Your response must be concise. 1.12. What is the ratio of the Mineral Rent(as % of GDP) of Coal in 1995 to that in 1998?
Your response must be concise. 3.17. What is the ratio of the Mineral Rent(as % of GDP) of Natural Gas in 1995 to that in 1998?
Your answer should be very brief. 1.03. What is the ratio of the Mineral Rent(as % of GDP) of Oil in 1995 to that in 1998?
Offer a very short reply. 1.54. What is the ratio of the Mineral Rent(as % of GDP) in Other Minerals in 1995 to that in 1998?
Ensure brevity in your answer.  1.2. What is the ratio of the Mineral Rent(as % of GDP) of Coal in 1995 to that in 1999?
Give a very brief answer. 4.63. What is the ratio of the Mineral Rent(as % of GDP) in Natural Gas in 1995 to that in 1999?
Keep it short and to the point. 1.07. What is the ratio of the Mineral Rent(as % of GDP) of Oil in 1995 to that in 1999?
Provide a short and direct response. 0.98. What is the ratio of the Mineral Rent(as % of GDP) in Other Minerals in 1995 to that in 1999?
Your response must be concise. 1.14. What is the ratio of the Mineral Rent(as % of GDP) in Coal in 1996 to that in 1997?
Your answer should be very brief. 1.37. What is the ratio of the Mineral Rent(as % of GDP) in Natural Gas in 1996 to that in 1997?
Your answer should be compact. 1.14. What is the ratio of the Mineral Rent(as % of GDP) of Oil in 1996 to that in 1997?
Keep it short and to the point. 1.12. What is the ratio of the Mineral Rent(as % of GDP) in Coal in 1996 to that in 1998?
Provide a short and direct response. 2.73. What is the ratio of the Mineral Rent(as % of GDP) in Natural Gas in 1996 to that in 1998?
Provide a short and direct response. 1.4. What is the ratio of the Mineral Rent(as % of GDP) of Oil in 1996 to that in 1998?
Your answer should be compact. 1.92. What is the ratio of the Mineral Rent(as % of GDP) of Other Minerals in 1996 to that in 1998?
Provide a short and direct response. 1.02. What is the ratio of the Mineral Rent(as % of GDP) of Coal in 1996 to that in 1999?
Offer a very short reply. 3.99. What is the ratio of the Mineral Rent(as % of GDP) of Natural Gas in 1996 to that in 1999?
Make the answer very short. 1.45. What is the ratio of the Mineral Rent(as % of GDP) of Oil in 1996 to that in 1999?
Offer a terse response. 1.22. What is the ratio of the Mineral Rent(as % of GDP) in Other Minerals in 1996 to that in 1999?
Give a very brief answer. 0.97. What is the ratio of the Mineral Rent(as % of GDP) in Coal in 1997 to that in 1998?
Your answer should be very brief. 1.99. What is the ratio of the Mineral Rent(as % of GDP) in Natural Gas in 1997 to that in 1998?
Ensure brevity in your answer.  1.23. What is the ratio of the Mineral Rent(as % of GDP) in Oil in 1997 to that in 1998?
Make the answer very short. 1.71. What is the ratio of the Mineral Rent(as % of GDP) of Other Minerals in 1997 to that in 1998?
Your response must be concise. 1.07. What is the ratio of the Mineral Rent(as % of GDP) of Coal in 1997 to that in 1999?
Keep it short and to the point. 2.91. What is the ratio of the Mineral Rent(as % of GDP) in Natural Gas in 1997 to that in 1999?
Your answer should be very brief. 1.27. What is the ratio of the Mineral Rent(as % of GDP) of Oil in 1997 to that in 1999?
Your response must be concise. 1.09. What is the ratio of the Mineral Rent(as % of GDP) of Other Minerals in 1997 to that in 1999?
Your answer should be very brief. 1.01. What is the ratio of the Mineral Rent(as % of GDP) in Coal in 1998 to that in 1999?
Offer a very short reply. 1.46. What is the ratio of the Mineral Rent(as % of GDP) in Natural Gas in 1998 to that in 1999?
Provide a succinct answer. 1.04. What is the ratio of the Mineral Rent(as % of GDP) of Oil in 1998 to that in 1999?
Give a very brief answer. 0.64. What is the ratio of the Mineral Rent(as % of GDP) in Other Minerals in 1998 to that in 1999?
Your response must be concise. 0.95. What is the difference between the highest and the second highest Mineral Rent(as % of GDP) of Natural Gas?
Ensure brevity in your answer.  0.05. What is the difference between the highest and the second highest Mineral Rent(as % of GDP) in Oil?
Give a very brief answer. 0.38. What is the difference between the highest and the second highest Mineral Rent(as % of GDP) of Other Minerals?
Give a very brief answer. 0.06. What is the difference between the highest and the lowest Mineral Rent(as % of GDP) of Coal?
Keep it short and to the point. 0. What is the difference between the highest and the lowest Mineral Rent(as % of GDP) of Natural Gas?
Make the answer very short. 0.13. What is the difference between the highest and the lowest Mineral Rent(as % of GDP) of Oil?
Your response must be concise. 1.68. What is the difference between the highest and the lowest Mineral Rent(as % of GDP) of Other Minerals?
Your response must be concise. 0.2. 